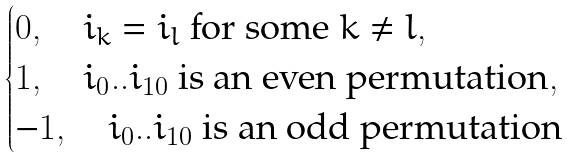<formula> <loc_0><loc_0><loc_500><loc_500>\begin{cases} 0 , \quad i _ { k } = i _ { l } \text { for some } k \neq l , \\ 1 , \quad i _ { 0 } . . i _ { 1 0 } \text { is an even permutation} , \\ - 1 , \quad i _ { 0 } . . i _ { 1 0 } \text { is an odd permutation} \end{cases}</formula> 